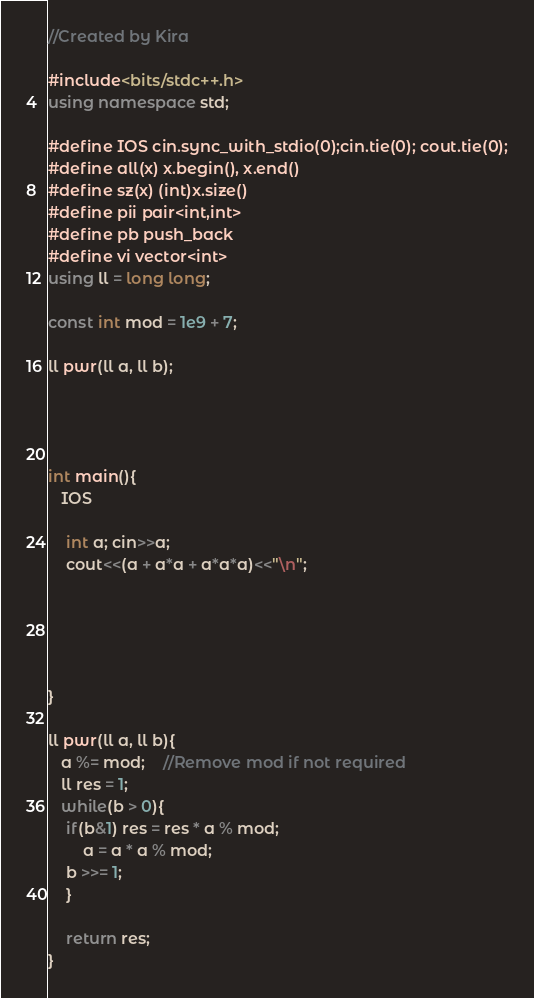Convert code to text. <code><loc_0><loc_0><loc_500><loc_500><_C++_>//Created by Kira

#include<bits/stdc++.h>
using namespace std;

#define IOS cin.sync_with_stdio(0);cin.tie(0); cout.tie(0);
#define all(x) x.begin(), x.end()
#define sz(x) (int)x.size()
#define pii pair<int,int> 
#define pb push_back
#define vi vector<int> 
using ll = long long;

const int mod = 1e9 + 7;

ll pwr(ll a, ll b);
    



int main(){
   IOS
   
    int a; cin>>a;
    cout<<(a + a*a + a*a*a)<<"\n";





}

ll pwr(ll a, ll b){
   a %= mod;	//Remove mod if not required
   ll res = 1;
   while(b > 0){
    if(b&1) res = res * a % mod;
        a = a * a % mod;
    b >>= 1;
    }

    return res;
}

</code> 